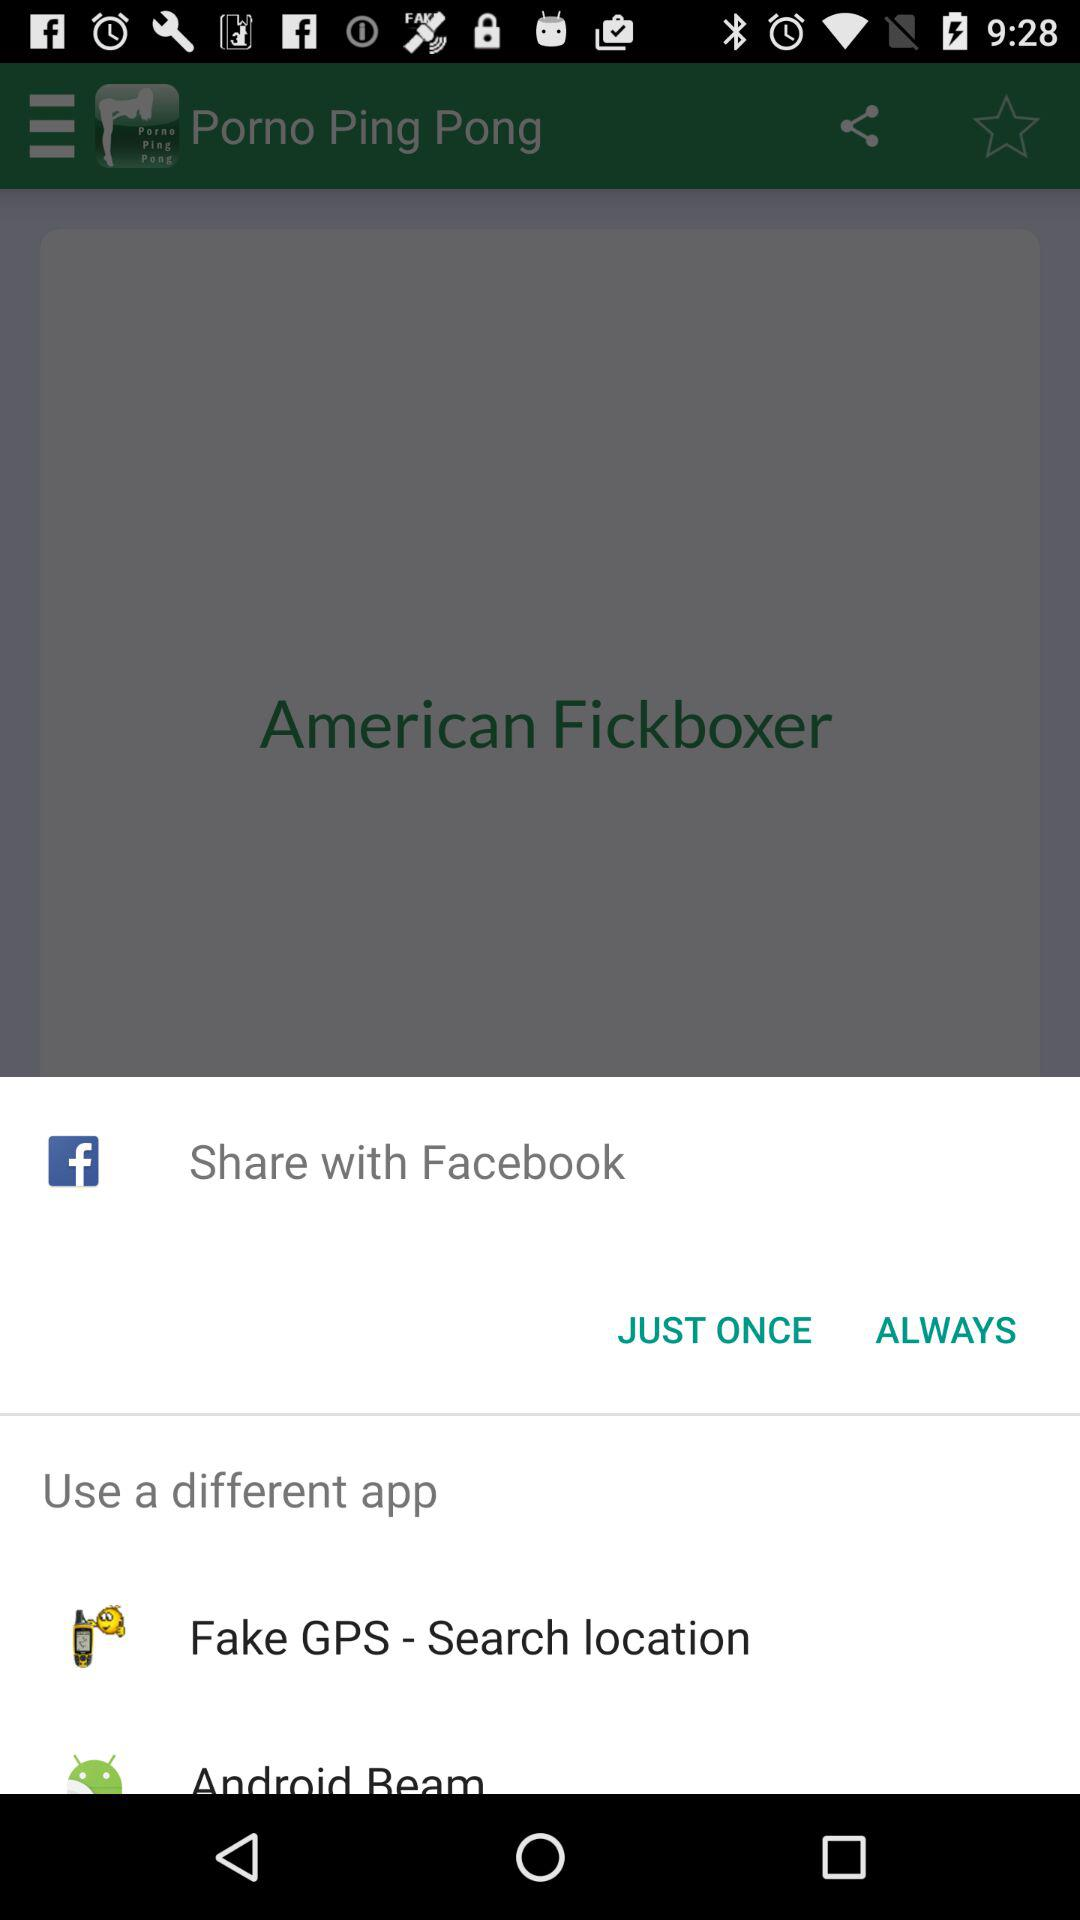What are the other options for sharing? The other options are "Facebook", "Fake GPS - Search location" and "Android Beam". 